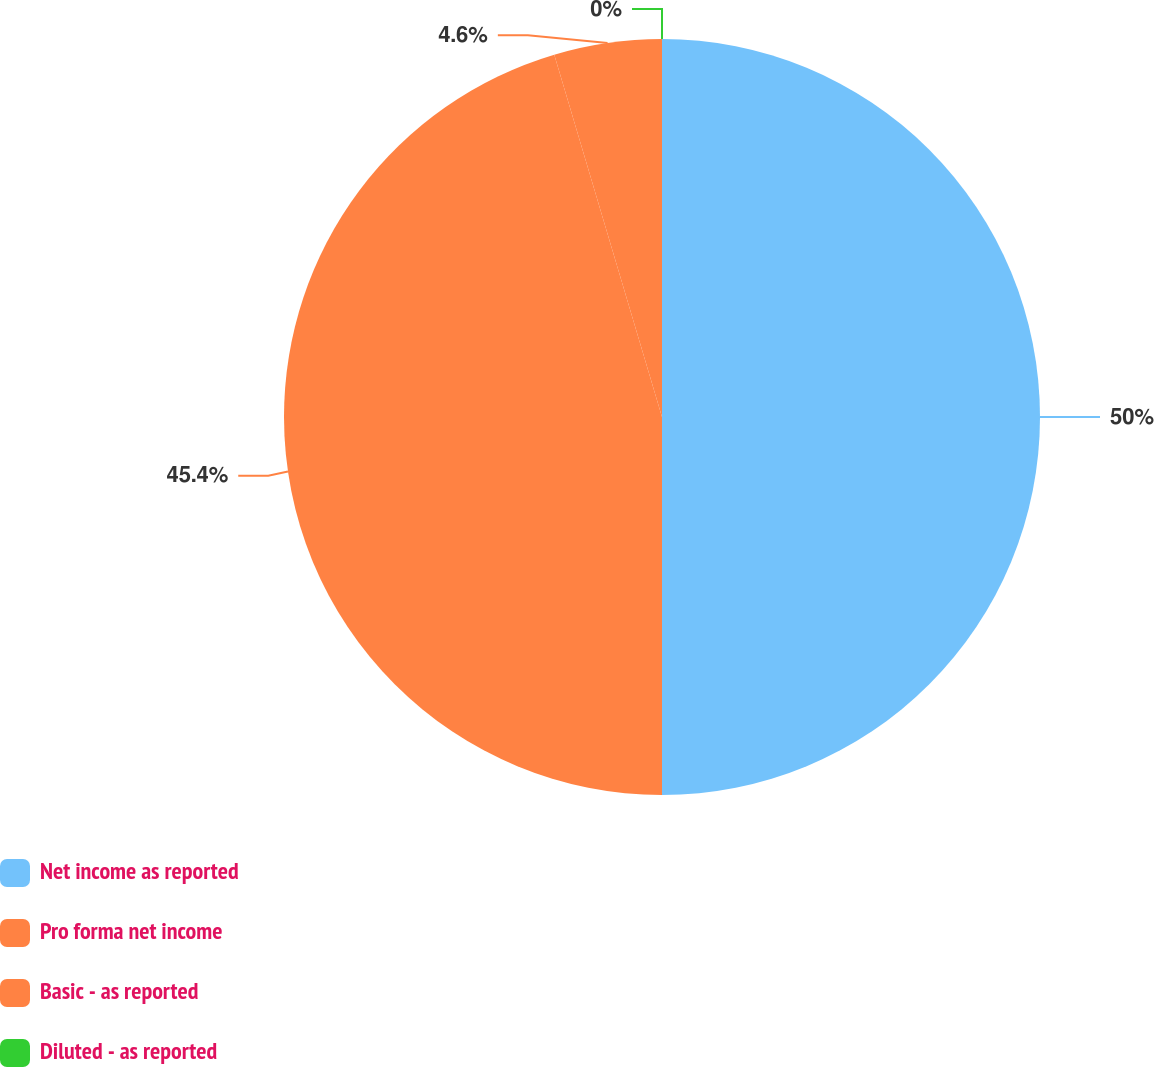Convert chart. <chart><loc_0><loc_0><loc_500><loc_500><pie_chart><fcel>Net income as reported<fcel>Pro forma net income<fcel>Basic - as reported<fcel>Diluted - as reported<nl><fcel>50.0%<fcel>45.4%<fcel>4.6%<fcel>0.0%<nl></chart> 